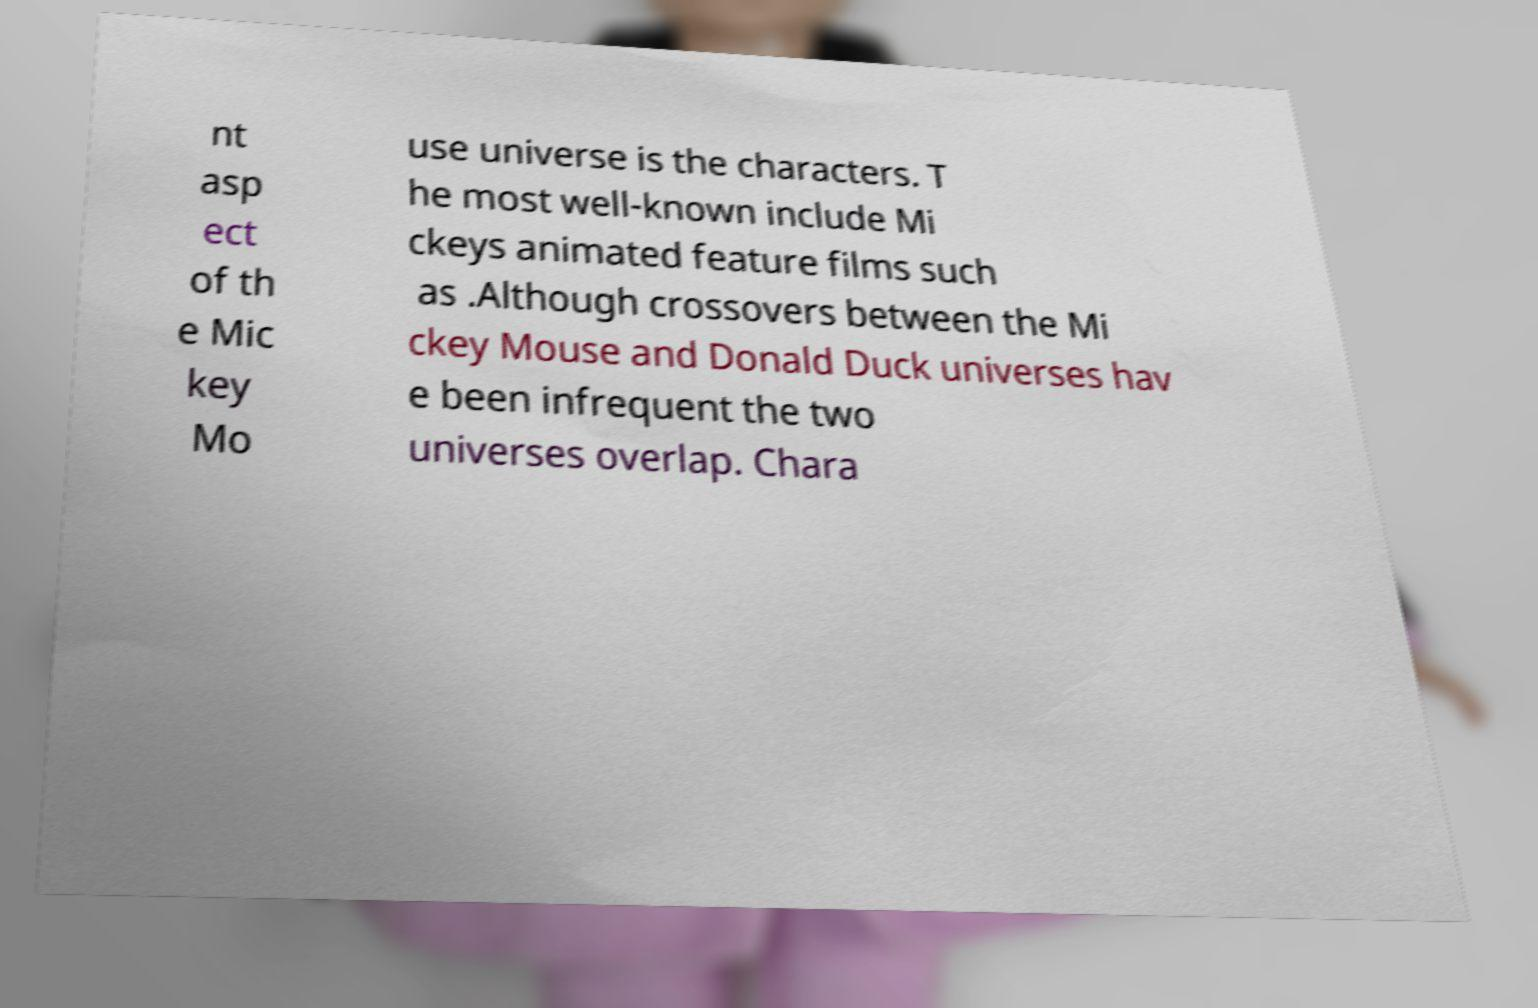Could you extract and type out the text from this image? nt asp ect of th e Mic key Mo use universe is the characters. T he most well-known include Mi ckeys animated feature films such as .Although crossovers between the Mi ckey Mouse and Donald Duck universes hav e been infrequent the two universes overlap. Chara 